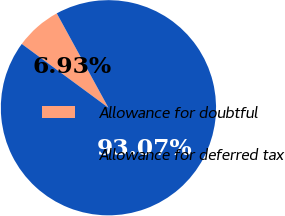Convert chart to OTSL. <chart><loc_0><loc_0><loc_500><loc_500><pie_chart><fcel>Allowance for doubtful<fcel>Allowance for deferred tax<nl><fcel>6.93%<fcel>93.07%<nl></chart> 